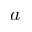Convert formula to latex. <formula><loc_0><loc_0><loc_500><loc_500>a</formula> 